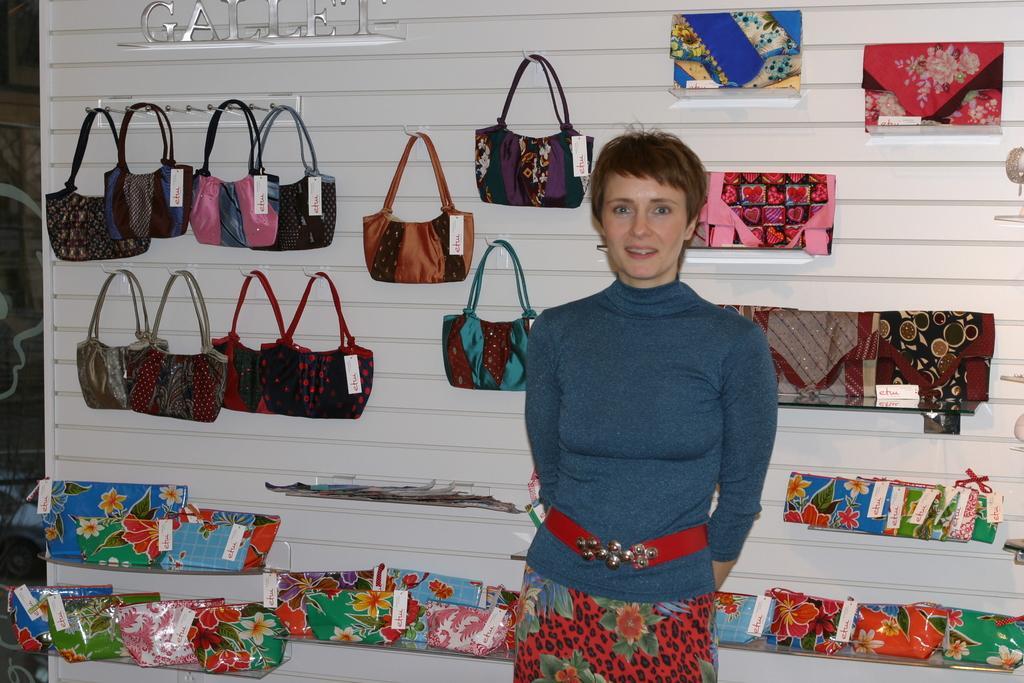In one or two sentences, can you explain what this image depicts? A lady wearing a blue and red dress also a belt is standing and smiling. Behind her there is a wall. On the wall there are many bags are hanged. Also there are clothes kept on the wall. 